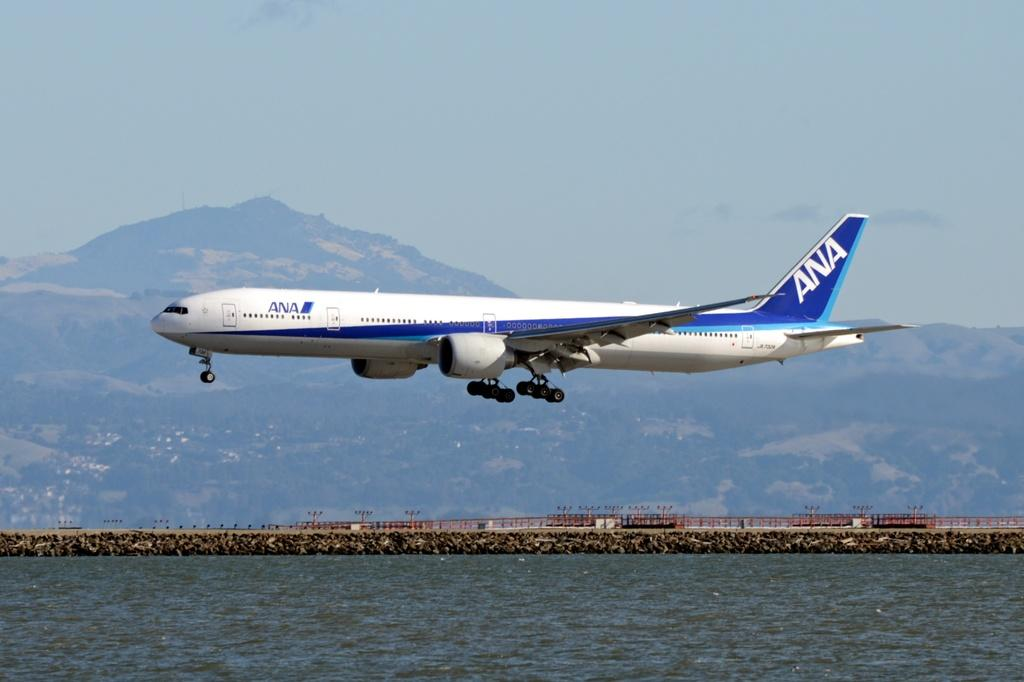Provide a one-sentence caption for the provided image. An ANA jet is flying nearly parallel to the water underneath it. 